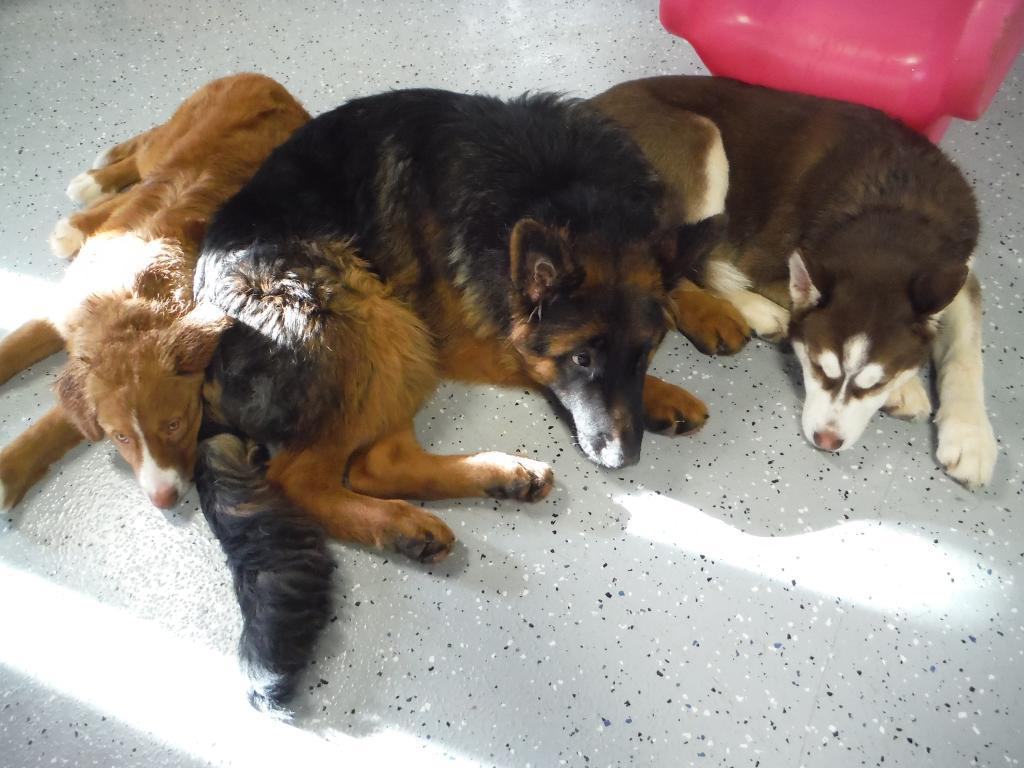How many dogs are present in the image? There are three dogs in the image. Where are the dogs located in the image? The dogs are on the floor in the image. Can you describe any specific features of the dogs? The provided facts do not mention any specific features of the dogs. What type of wave can be seen crashing on the shore in the image? There is no wave or shore present in the image; it features three dogs on the floor. What is the tendency of the boys in the image? There are no boys present in the image, so it is not possible to determine their tendency. 